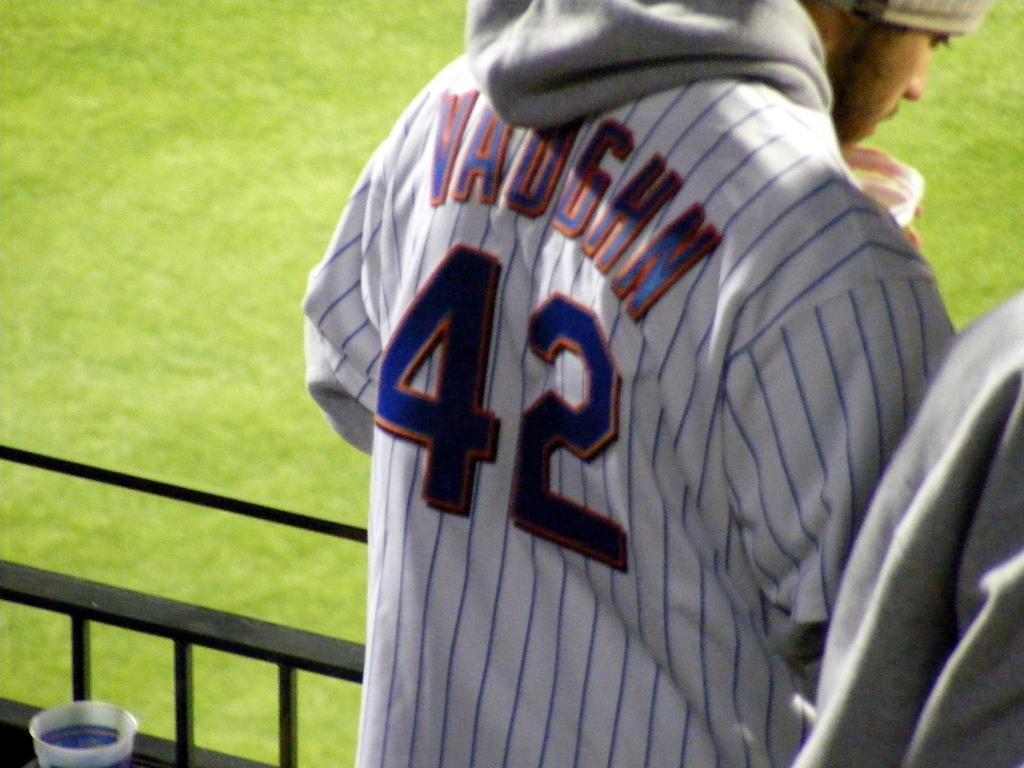Could you give a brief overview of what you see in this image? In this picture we can see a person holding a cup in his hand. There is another person on the right side. We can see a cup and a fence on the left side. Some grass is visible on the ground. 